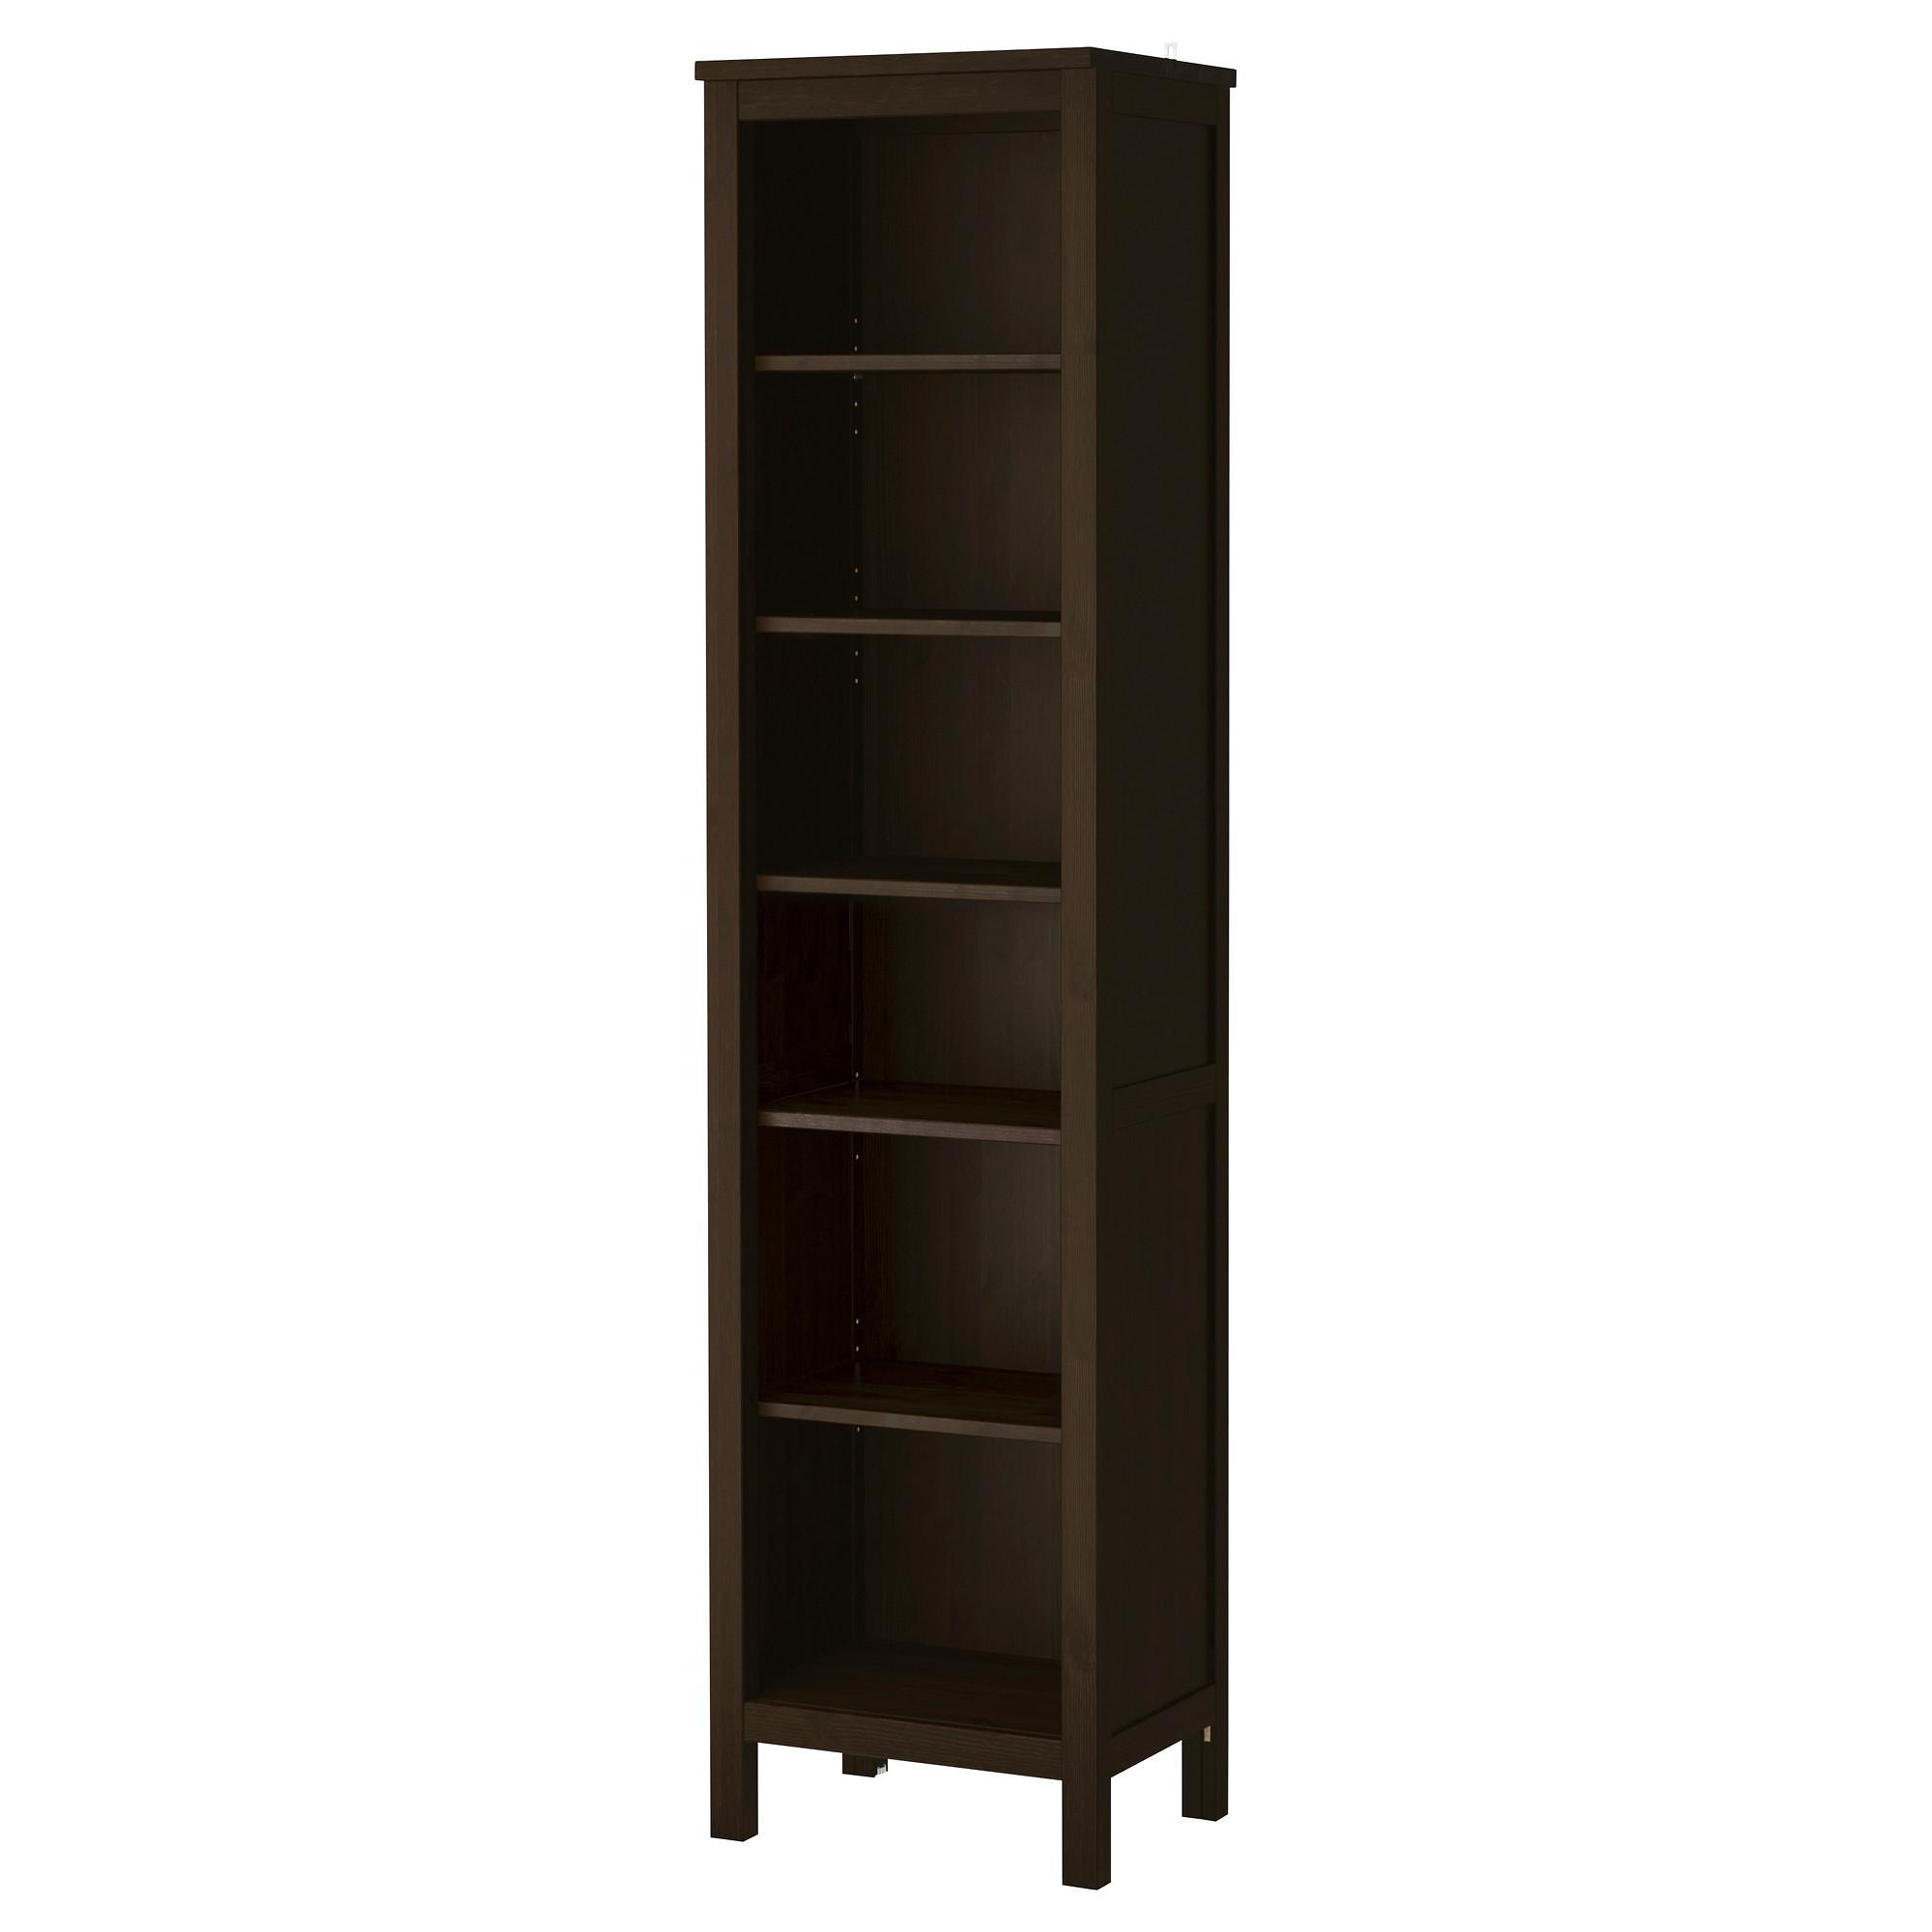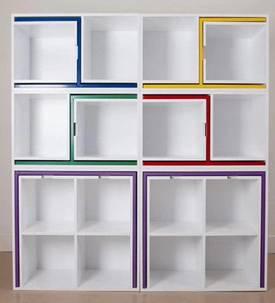The first image is the image on the left, the second image is the image on the right. Given the left and right images, does the statement "The left image contains a dark brown bookshelf." hold true? Answer yes or no. Yes. The first image is the image on the left, the second image is the image on the right. Analyze the images presented: Is the assertion "In one image, a tall plain boxy bookshelf is a dark walnut color, stands on short legs, and has six shelves, all of them empty." valid? Answer yes or no. Yes. 